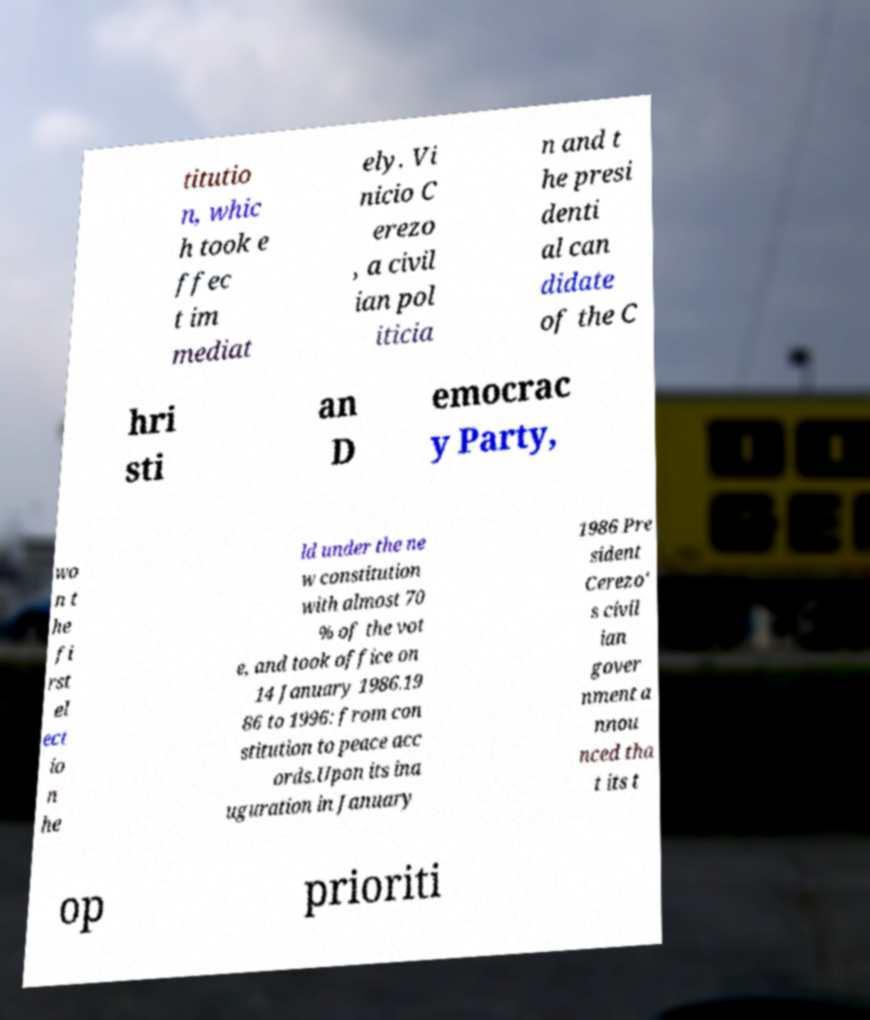Could you assist in decoding the text presented in this image and type it out clearly? titutio n, whic h took e ffec t im mediat ely. Vi nicio C erezo , a civil ian pol iticia n and t he presi denti al can didate of the C hri sti an D emocrac y Party, wo n t he fi rst el ect io n he ld under the ne w constitution with almost 70 % of the vot e, and took office on 14 January 1986.19 86 to 1996: from con stitution to peace acc ords.Upon its ina uguration in January 1986 Pre sident Cerezo' s civil ian gover nment a nnou nced tha t its t op prioriti 